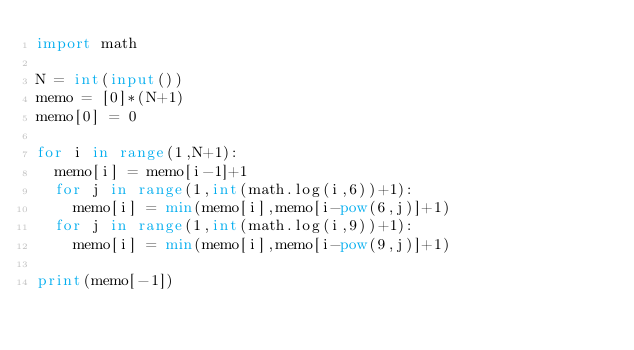<code> <loc_0><loc_0><loc_500><loc_500><_Python_>import math

N = int(input())
memo = [0]*(N+1)
memo[0] = 0

for i in range(1,N+1):
	memo[i] = memo[i-1]+1
	for j in range(1,int(math.log(i,6))+1):
		memo[i] = min(memo[i],memo[i-pow(6,j)]+1)
	for j in range(1,int(math.log(i,9))+1):
		memo[i] = min(memo[i],memo[i-pow(9,j)]+1)

print(memo[-1])
</code> 